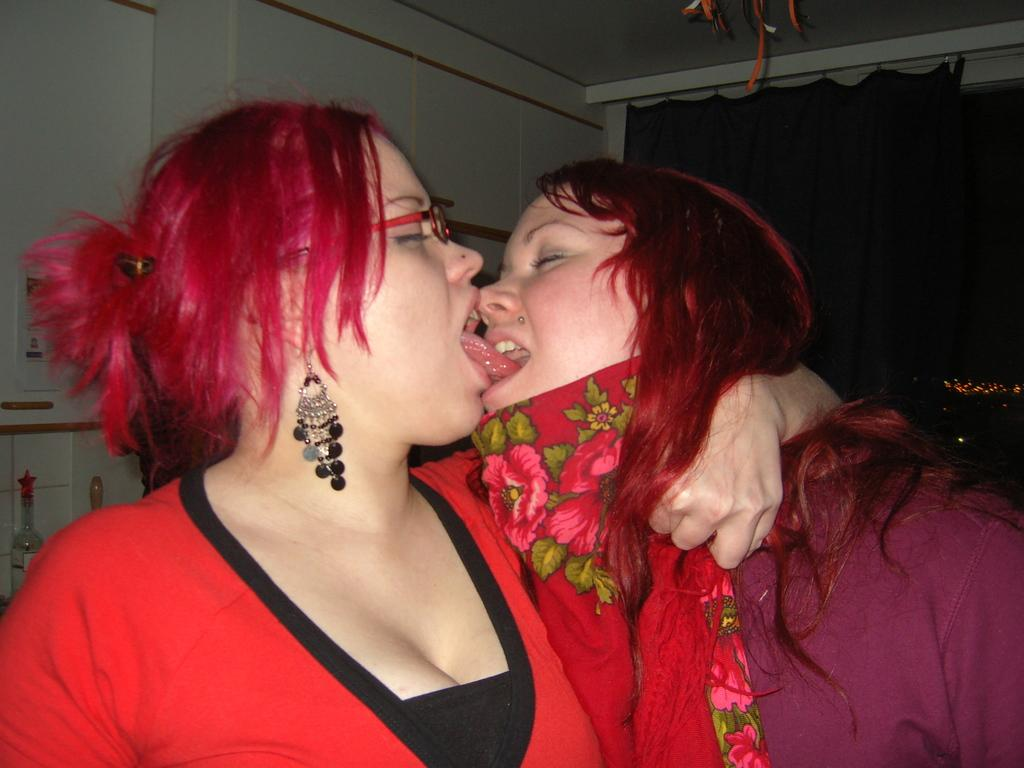What type of view is shown in the image? The image is an inside view. How many people are present in the image? There are two women in the image. What are the women wearing? The women are wearing jackets. What can be seen in the background of the image? There is a wall and a curtain in the background of the image. What is located on the left side of the image? There are objects on the left side of the image. What type of breakfast is being prepared by the women in the image? There is no indication of any breakfast preparation in the image; it only shows two women wearing jackets in an inside view. What is the mouth of the woman on the right side of the image doing? There is no mouth visible in the image, as it is a photograph of two women wearing jackets in an inside view. 